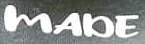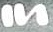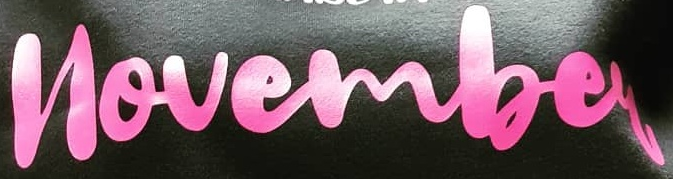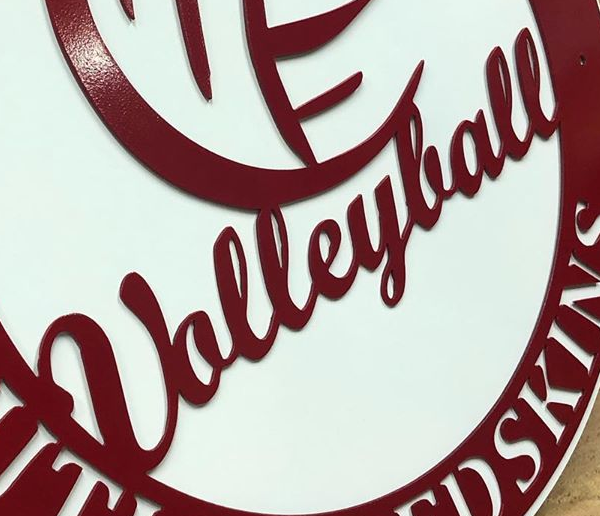Read the text from these images in sequence, separated by a semicolon. MADE; In; novembey; Ualleylall 